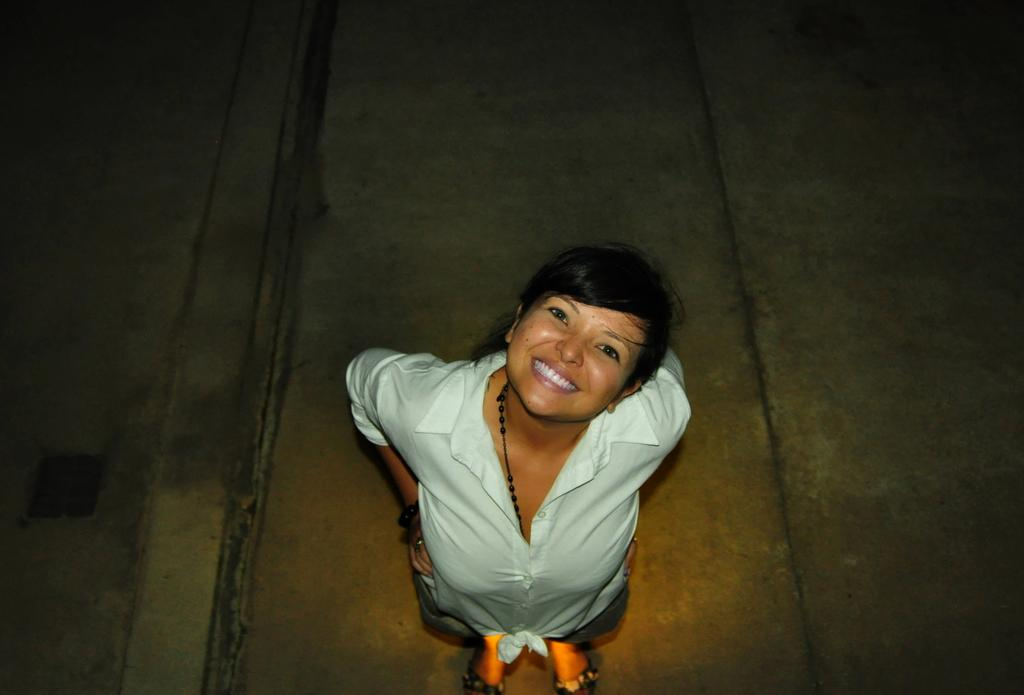What is present in the image? There is a person in the image. What is the person doing in the image? The person is standing. What can be observed about the person's attire? The person is wearing clothes. Reasoning: Let'ing: Let's think step by step in order to produce the conversation. We start by identifying the main subject in the image, which is the person. Then, we describe the person's actions and appearance based on the provided facts. Each question is designed to elicit a specific detail about the image that is known from the given information. Absurd Question/Answer: What type of jar can be seen in the person's hand in the image? There is no jar present in the image, and the person's hands are not visible. What type of pest is visible on the person's shoulder in the image? There is no pest visible on the person's shoulder in the image; the person's shoulders are not visible in the image. --- Facts: 1. There is a car in the image. 2. The car is red. 3. The car has four wheels. 4. The car has a license plate. 5. The car is parked on the street. Absurd Topics: bird, ocean, mountain Conversation: What is the main subject of the image? The main subject of the image is a car. What color is the car? The car is red. How many wheels does the car have? The car has four wheels. Does the car have any identifying features? Yes, the car has a license plate. Where is the car located in the image? The car is parked on the street. Reasoning: Let's think step by step in order to produce the conversation. We start by identifying the main subject in the image, which is the car. Then, we describe the car's color, number of wheels, and the presence of a license plate based on the provided facts. Finally, we mention the car's location in the image, which is parked on the street. Each question is designed to elicit a specific 